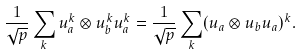Convert formula to latex. <formula><loc_0><loc_0><loc_500><loc_500>\frac { 1 } { \sqrt { p } } \sum _ { k } u _ { a } ^ { k } \otimes u _ { b } ^ { k } u _ { a } ^ { k } = \frac { 1 } { \sqrt { p } } \sum _ { k } ( u _ { a } \otimes u _ { b } u _ { a } ) ^ { k } .</formula> 